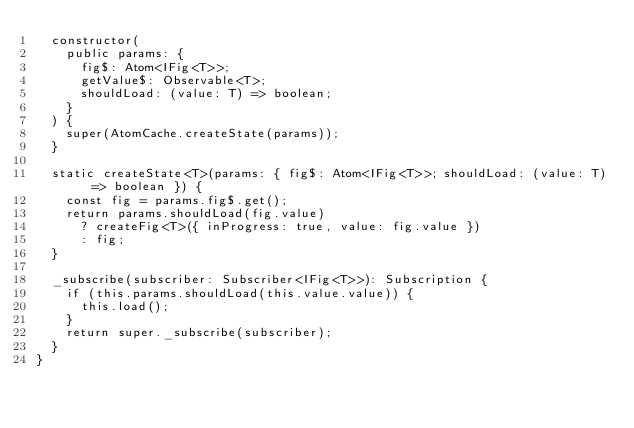<code> <loc_0><loc_0><loc_500><loc_500><_TypeScript_>  constructor(
    public params: {
      fig$: Atom<IFig<T>>;
      getValue$: Observable<T>;
      shouldLoad: (value: T) => boolean;
    }
  ) {
    super(AtomCache.createState(params));
  }

  static createState<T>(params: { fig$: Atom<IFig<T>>; shouldLoad: (value: T) => boolean }) {
    const fig = params.fig$.get();
    return params.shouldLoad(fig.value)
      ? createFig<T>({ inProgress: true, value: fig.value })
      : fig;
  }

  _subscribe(subscriber: Subscriber<IFig<T>>): Subscription {
    if (this.params.shouldLoad(this.value.value)) {
      this.load();
    }
    return super._subscribe(subscriber);
  }
}
</code> 